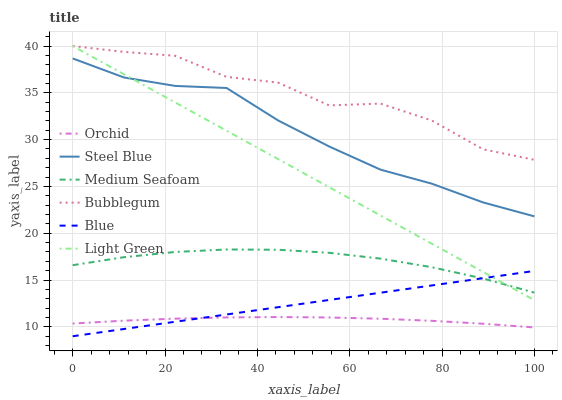Does Orchid have the minimum area under the curve?
Answer yes or no. Yes. Does Bubblegum have the maximum area under the curve?
Answer yes or no. Yes. Does Steel Blue have the minimum area under the curve?
Answer yes or no. No. Does Steel Blue have the maximum area under the curve?
Answer yes or no. No. Is Blue the smoothest?
Answer yes or no. Yes. Is Bubblegum the roughest?
Answer yes or no. Yes. Is Steel Blue the smoothest?
Answer yes or no. No. Is Steel Blue the roughest?
Answer yes or no. No. Does Blue have the lowest value?
Answer yes or no. Yes. Does Steel Blue have the lowest value?
Answer yes or no. No. Does Light Green have the highest value?
Answer yes or no. Yes. Does Steel Blue have the highest value?
Answer yes or no. No. Is Blue less than Steel Blue?
Answer yes or no. Yes. Is Steel Blue greater than Blue?
Answer yes or no. Yes. Does Blue intersect Light Green?
Answer yes or no. Yes. Is Blue less than Light Green?
Answer yes or no. No. Is Blue greater than Light Green?
Answer yes or no. No. Does Blue intersect Steel Blue?
Answer yes or no. No. 